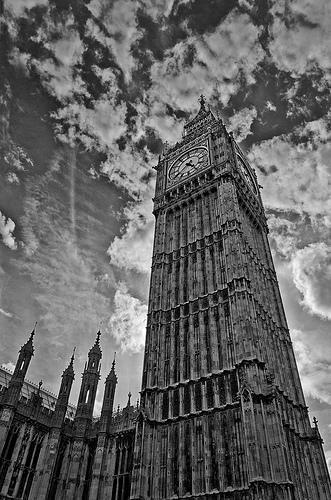How many tall towers are there?
Give a very brief answer. 1. 